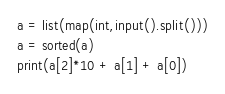Convert code to text. <code><loc_0><loc_0><loc_500><loc_500><_Python_>a = list(map(int,input().split()))
a = sorted(a)
print(a[2]*10 + a[1] + a[0])</code> 